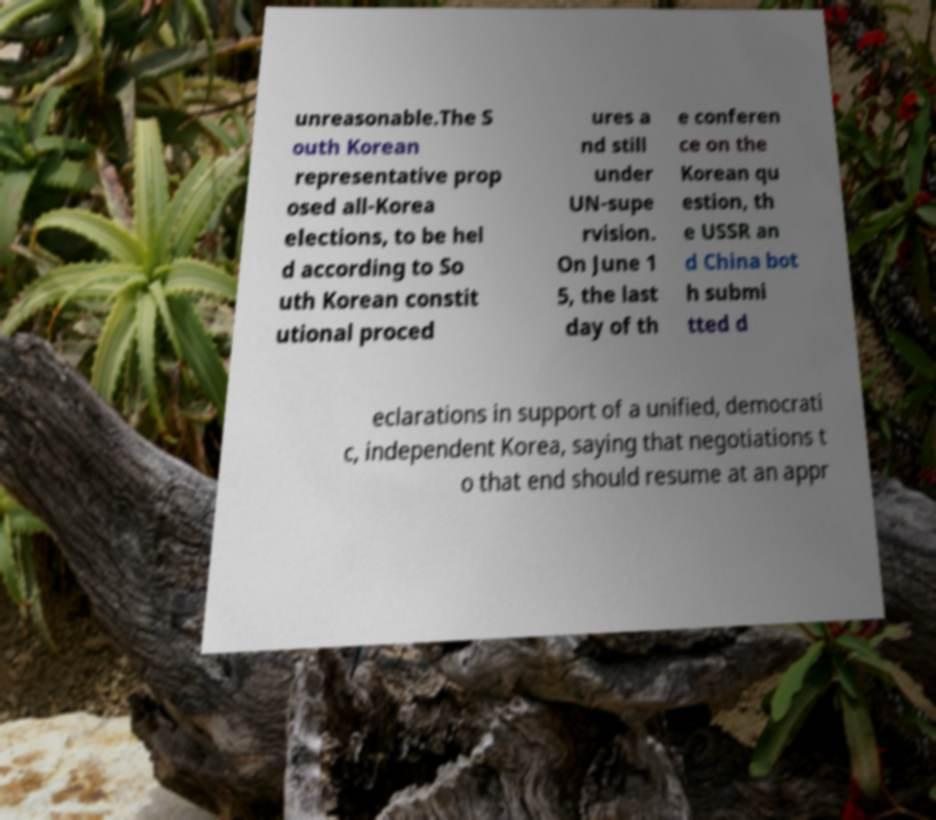Please read and relay the text visible in this image. What does it say? unreasonable.The S outh Korean representative prop osed all-Korea elections, to be hel d according to So uth Korean constit utional proced ures a nd still under UN-supe rvision. On June 1 5, the last day of th e conferen ce on the Korean qu estion, th e USSR an d China bot h submi tted d eclarations in support of a unified, democrati c, independent Korea, saying that negotiations t o that end should resume at an appr 